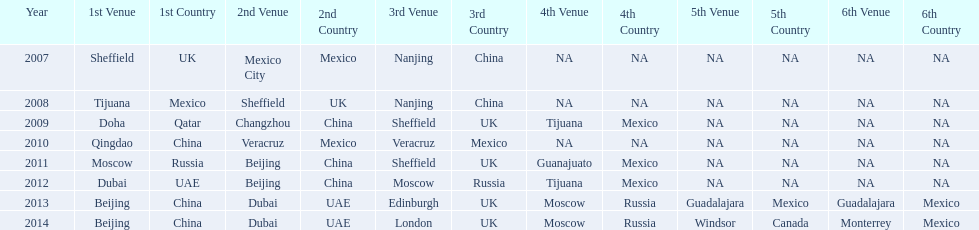Which two venue has no nations from 2007-2012 5th Venue, 6th Venue. 